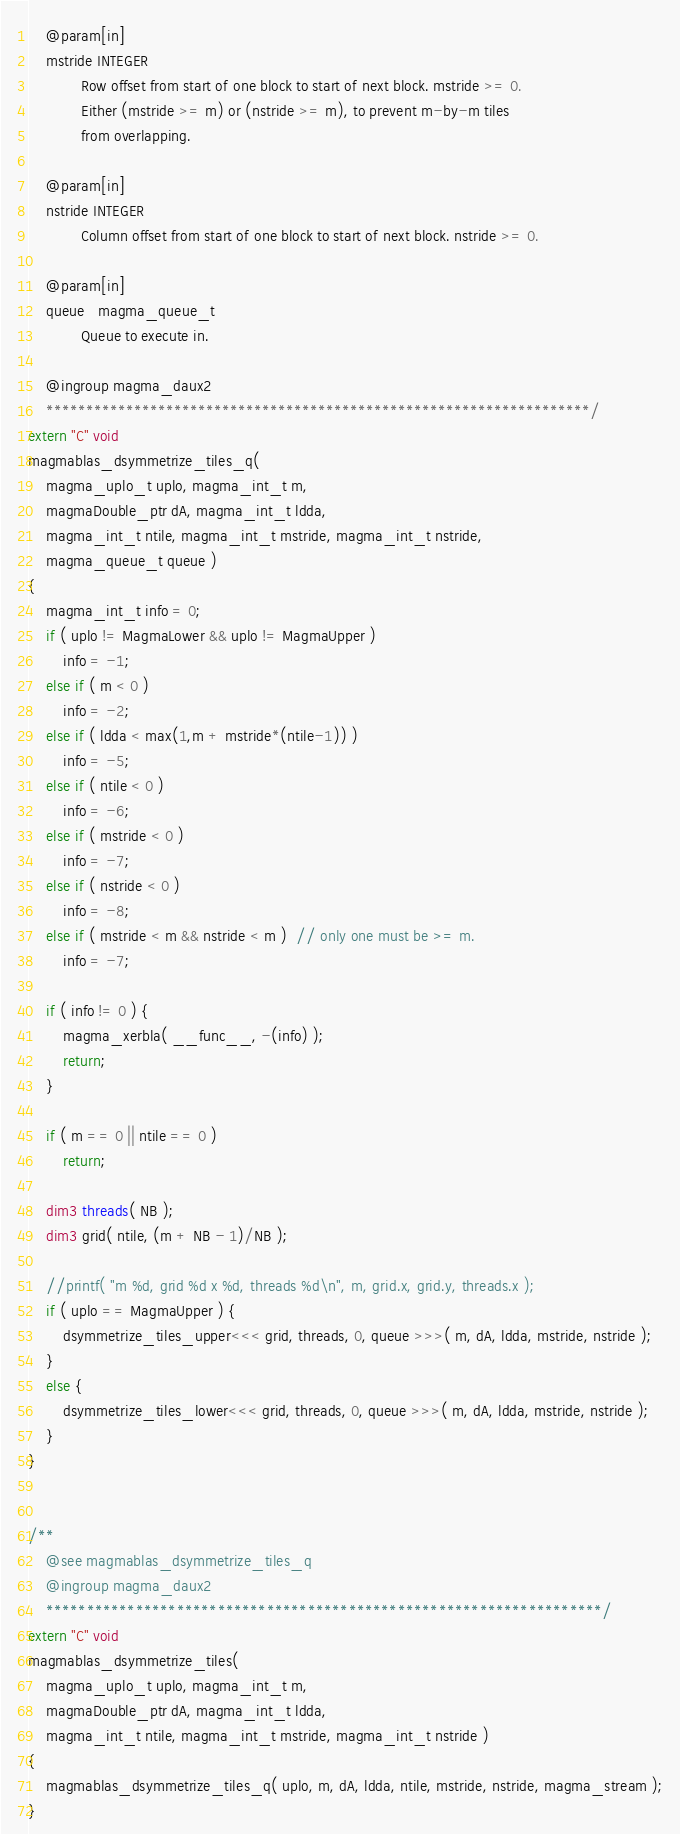Convert code to text. <code><loc_0><loc_0><loc_500><loc_500><_Cuda_>    @param[in]
    mstride INTEGER
            Row offset from start of one block to start of next block. mstride >= 0.
            Either (mstride >= m) or (nstride >= m), to prevent m-by-m tiles
            from overlapping.
    
    @param[in]
    nstride INTEGER
            Column offset from start of one block to start of next block. nstride >= 0.
    
    @param[in]
    queue   magma_queue_t
            Queue to execute in.

    @ingroup magma_daux2
    ********************************************************************/
extern "C" void
magmablas_dsymmetrize_tiles_q(
    magma_uplo_t uplo, magma_int_t m,
    magmaDouble_ptr dA, magma_int_t ldda,
    magma_int_t ntile, magma_int_t mstride, magma_int_t nstride,
    magma_queue_t queue )
{
    magma_int_t info = 0;
    if ( uplo != MagmaLower && uplo != MagmaUpper )
        info = -1;
    else if ( m < 0 )
        info = -2;
    else if ( ldda < max(1,m + mstride*(ntile-1)) )
        info = -5;
    else if ( ntile < 0 )
        info = -6;
    else if ( mstride < 0 )
        info = -7;
    else if ( nstride < 0 )
        info = -8;
    else if ( mstride < m && nstride < m )  // only one must be >= m.
        info = -7;
    
    if ( info != 0 ) {
        magma_xerbla( __func__, -(info) );
        return;
    }
    
    if ( m == 0 || ntile == 0 )
        return;
    
    dim3 threads( NB );
    dim3 grid( ntile, (m + NB - 1)/NB );
    
    //printf( "m %d, grid %d x %d, threads %d\n", m, grid.x, grid.y, threads.x );
    if ( uplo == MagmaUpper ) {
        dsymmetrize_tiles_upper<<< grid, threads, 0, queue >>>( m, dA, ldda, mstride, nstride );
    }
    else {
        dsymmetrize_tiles_lower<<< grid, threads, 0, queue >>>( m, dA, ldda, mstride, nstride );
    }
}


/**
    @see magmablas_dsymmetrize_tiles_q
    @ingroup magma_daux2
    ********************************************************************/
extern "C" void
magmablas_dsymmetrize_tiles(
    magma_uplo_t uplo, magma_int_t m,
    magmaDouble_ptr dA, magma_int_t ldda,
    magma_int_t ntile, magma_int_t mstride, magma_int_t nstride )
{
    magmablas_dsymmetrize_tiles_q( uplo, m, dA, ldda, ntile, mstride, nstride, magma_stream );
}
</code> 